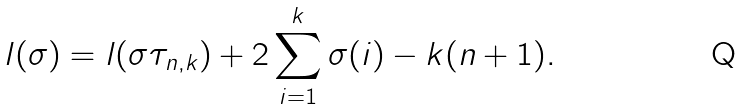Convert formula to latex. <formula><loc_0><loc_0><loc_500><loc_500>l ( \sigma ) = l ( \sigma \tau _ { n , k } ) + 2 \sum _ { i = 1 } ^ { k } \sigma ( i ) - k ( n + 1 ) .</formula> 